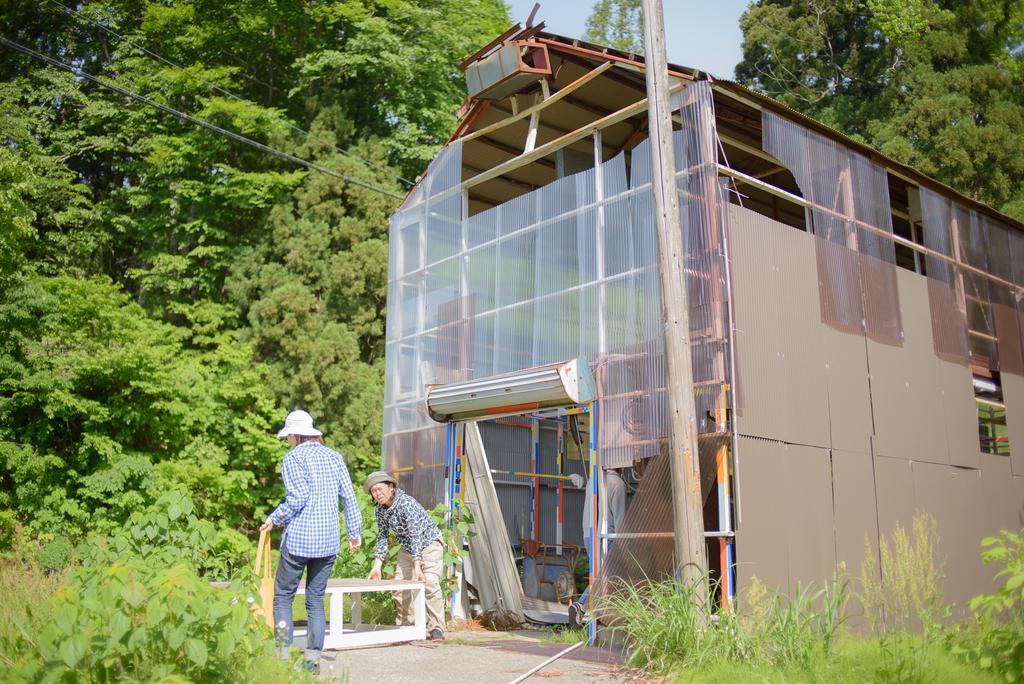Describe this image in one or two sentences. In this picture we can see two persons wearing hats, standing and doing some work, on the right side of the picture there is shed and in the background of the picture there are some trees and there is clear sky. 